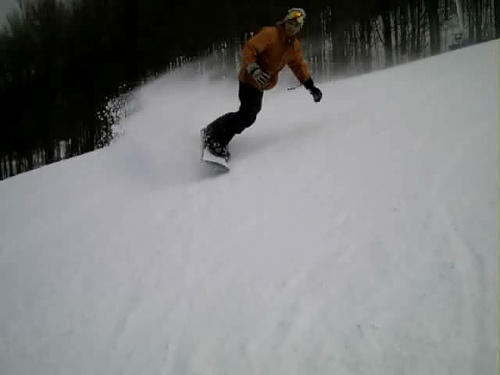Describe the objects in this image and their specific colors. I can see people in gray, black, maroon, and darkgreen tones and snowboard in gray, darkgray, and black tones in this image. 